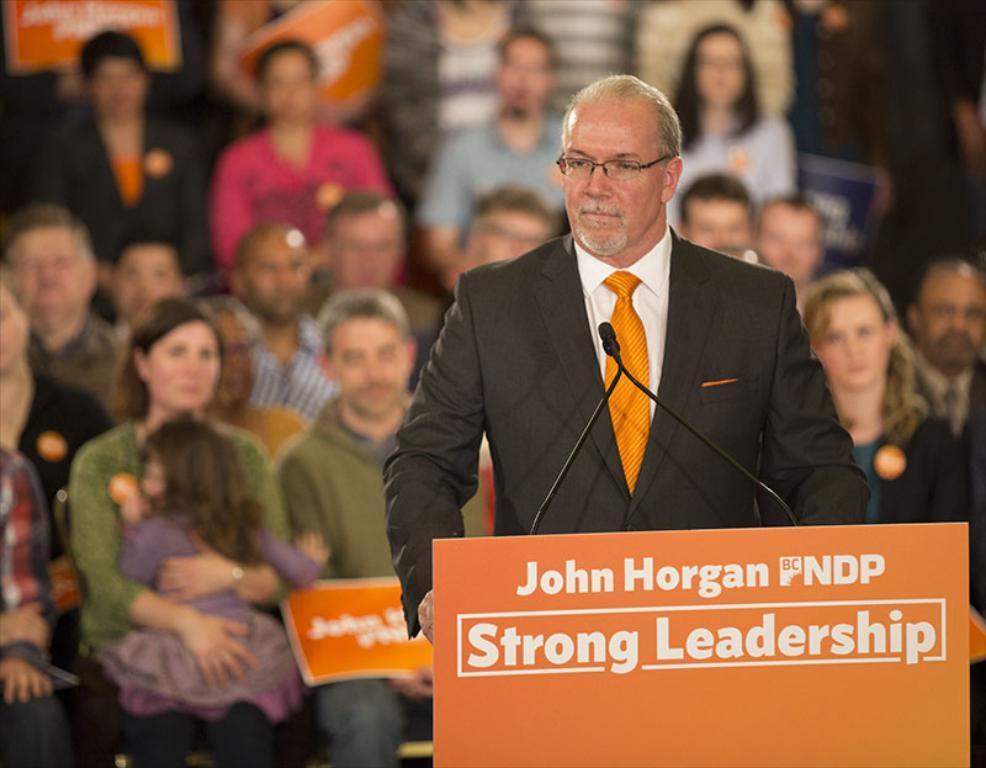Can you describe this image briefly? In the center of the image we can see one person is standing and he is wearing glasses and he is in a different costume. In front of him, we can see microphones and one board with some text. In the background, we can see a few people are sitting. Among them, we can see one person is holding one kid and a few people are holding boards with some text. 